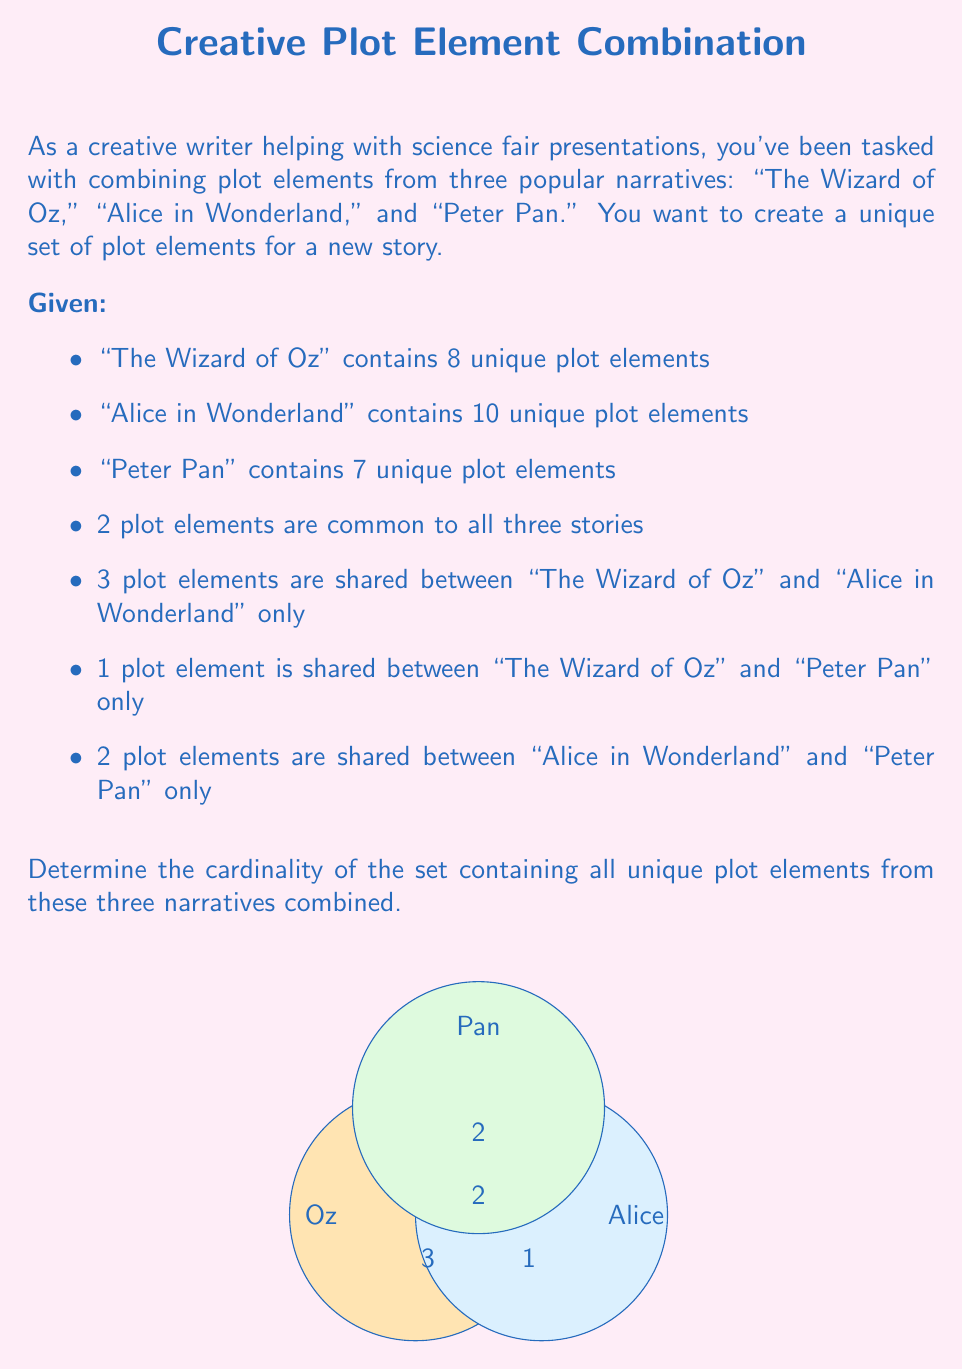What is the answer to this math problem? Let's approach this step-by-step using set theory:

1) Let's define our sets:
   $O$: plot elements in "The Wizard of Oz"
   $A$: plot elements in "Alice in Wonderland"
   $P$: plot elements in "Peter Pan"

2) We're looking for $|O \cup A \cup P|$, the cardinality of the union of all three sets.

3) We can use the Inclusion-Exclusion Principle:

   $|O \cup A \cup P| = |O| + |A| + |P| - |O \cap A| - |O \cap P| - |A \cap P| + |O \cap A \cap P|$

4) We know:
   $|O| = 8$, $|A| = 10$, $|P| = 7$
   $|O \cap A \cap P| = 2$
   $|O \cap A| = 3 + 2 = 5$ (shared elements between O and A only, plus elements common to all three)
   $|O \cap P| = 1 + 2 = 3$ (shared elements between O and P only, plus elements common to all three)
   $|A \cap P| = 2 + 2 = 4$ (shared elements between A and P only, plus elements common to all three)

5) Now we can substitute these values:

   $|O \cup A \cup P| = 8 + 10 + 7 - 5 - 3 - 4 + 2$

6) Simplifying:
   $|O \cup A \cup P| = 25 - 12 + 2 = 15$

Therefore, the set of all unique plot elements contains 15 elements.
Answer: 15 